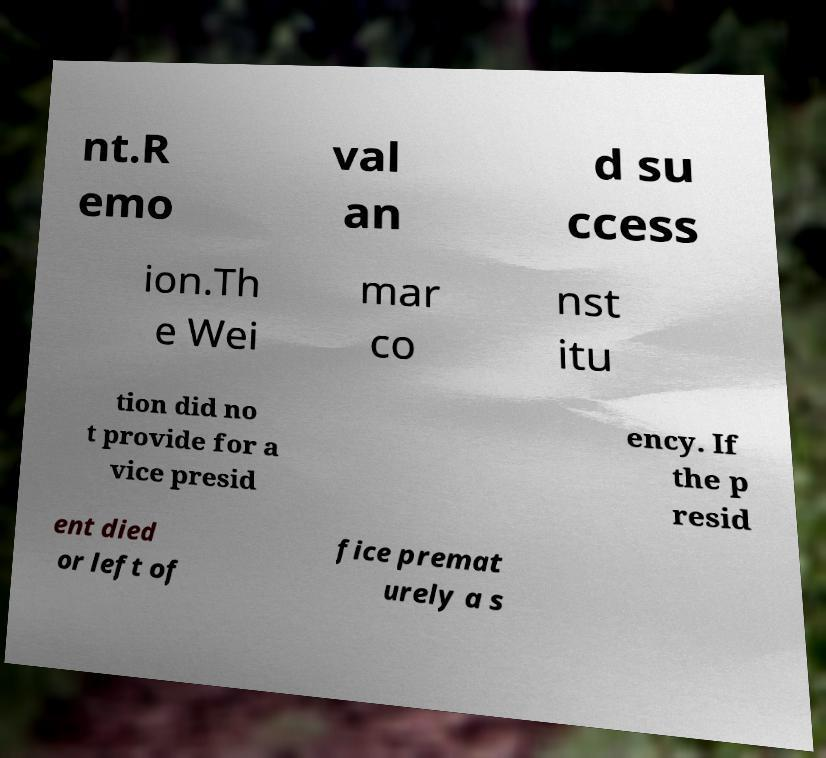Could you extract and type out the text from this image? nt.R emo val an d su ccess ion.Th e Wei mar co nst itu tion did no t provide for a vice presid ency. If the p resid ent died or left of fice premat urely a s 